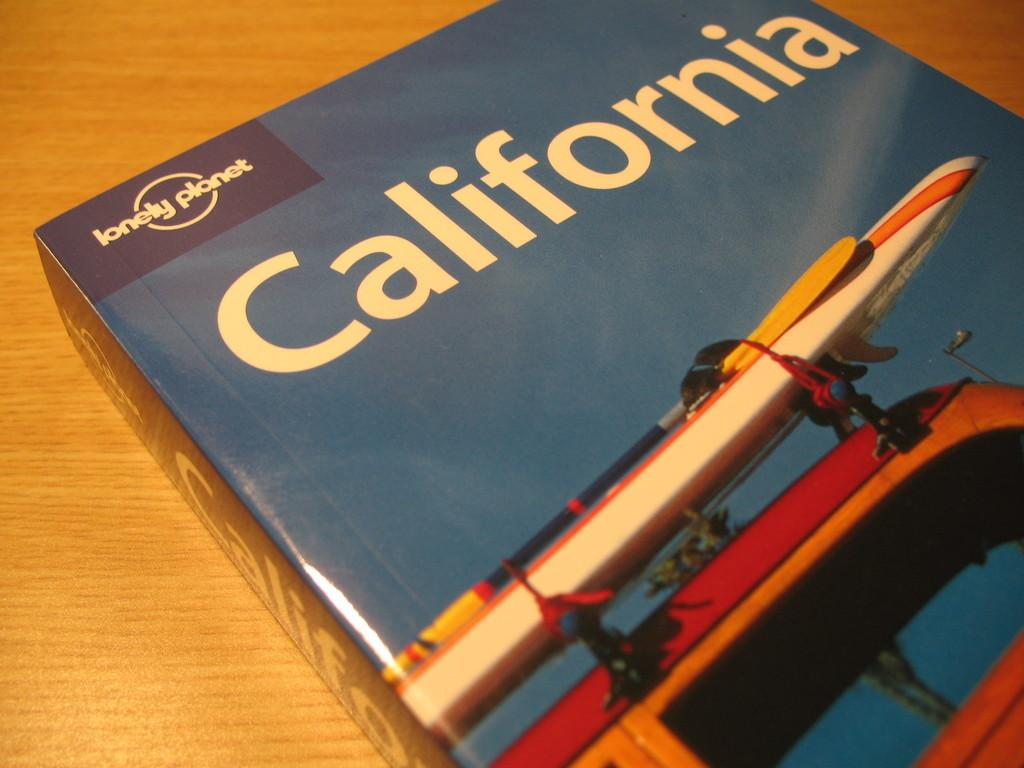<image>
Share a concise interpretation of the image provided. A Lonely Planet travel guide book for California. 